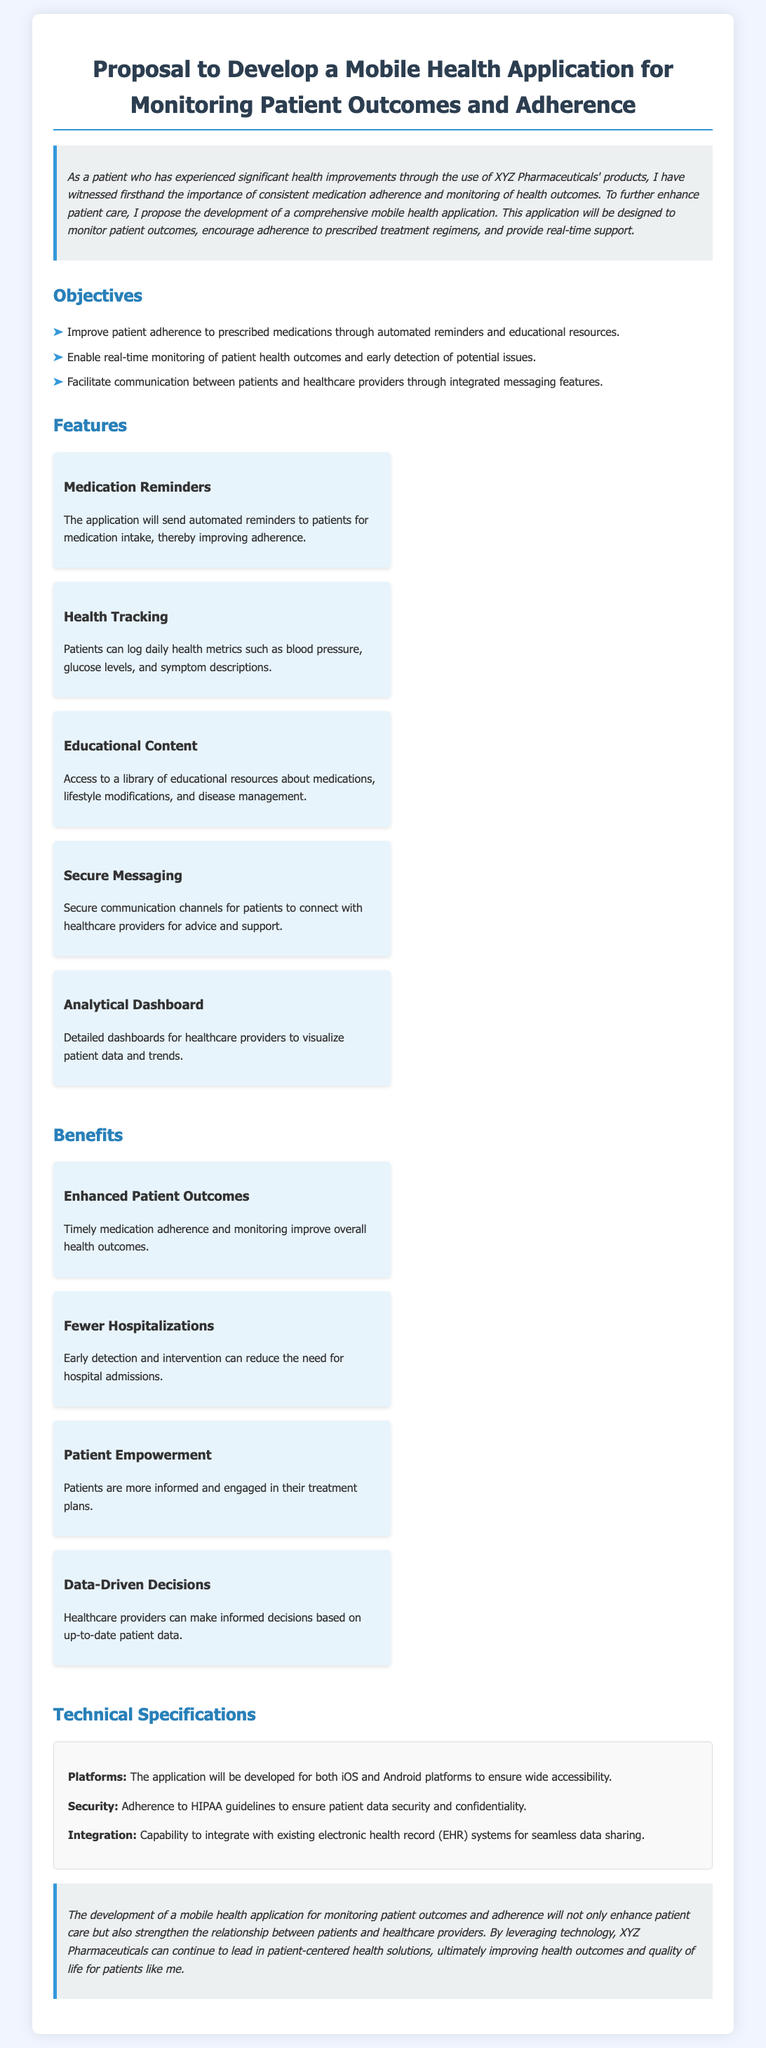What is the main purpose of the proposed application? The main purpose is to monitor patient outcomes and encourage adherence to prescribed treatment regimens.
Answer: Monitor patient outcomes and encourage adherence How many objectives are listed in the proposal? The proposal lists three specific objectives aimed at enhancing patient care and medication adherence.
Answer: Three What feature will improve medication adherence? The application will send automated reminders to patients regarding medication intake.
Answer: Medication Reminders What type of content will the app provide for education? The application will provide access to a library of educational resources about medications and lifestyle modifications.
Answer: Educational resources What benefit is associated with early detection of issues? Early detection and intervention can reduce the need for hospital admissions.
Answer: Fewer Hospitalizations Which platforms will the application be developed for? The application will be developed for both iOS and Android platforms.
Answer: iOS and Android What is a key requirement for patient data security mentioned in the proposal? Adherence to HIPAA guidelines is essential to ensure patient data security.
Answer: HIPAA guidelines What type of messaging feature will the application include? The application will include secure messaging channels for patients to connect with healthcare providers.
Answer: Secure Messaging What is the intended impact of the mobile health application on patient care? The application aims to enhance patient care and strengthen the relationship between patients and healthcare providers.
Answer: Enhance patient care 